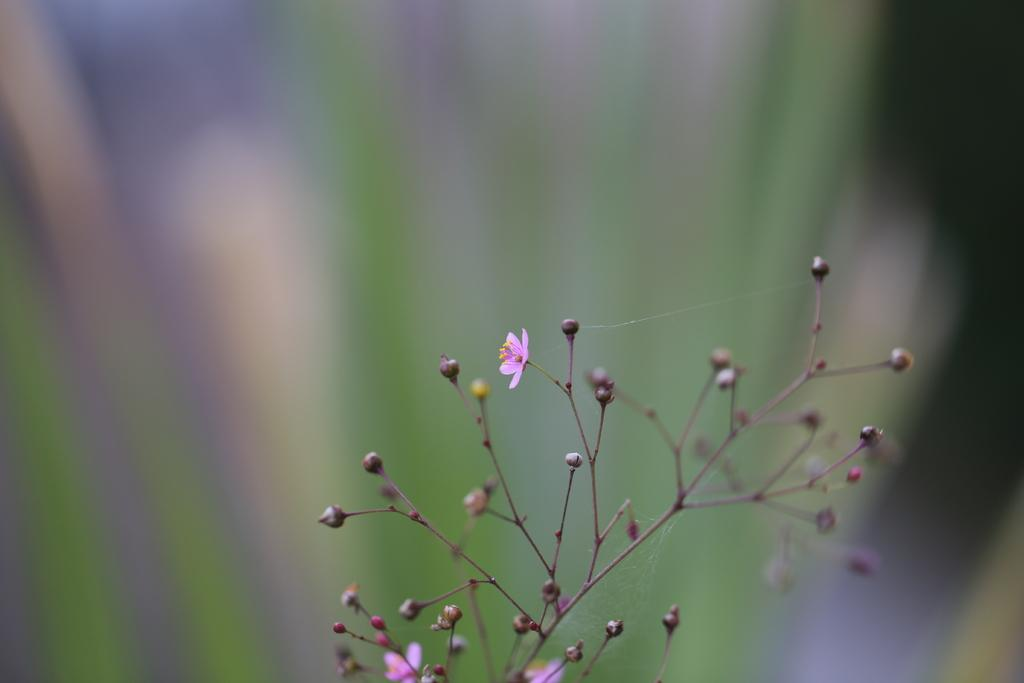What is present in the image? There is a plant in the image. Can you describe the plant in more detail? The plant has flowers and buds. What can be observed about the background of the image? The background of the image is blurred. What type of truck can be seen driving through the pipe in the image? There is no truck or pipe present in the image; it features a plant with flowers and buds against a blurred background. 